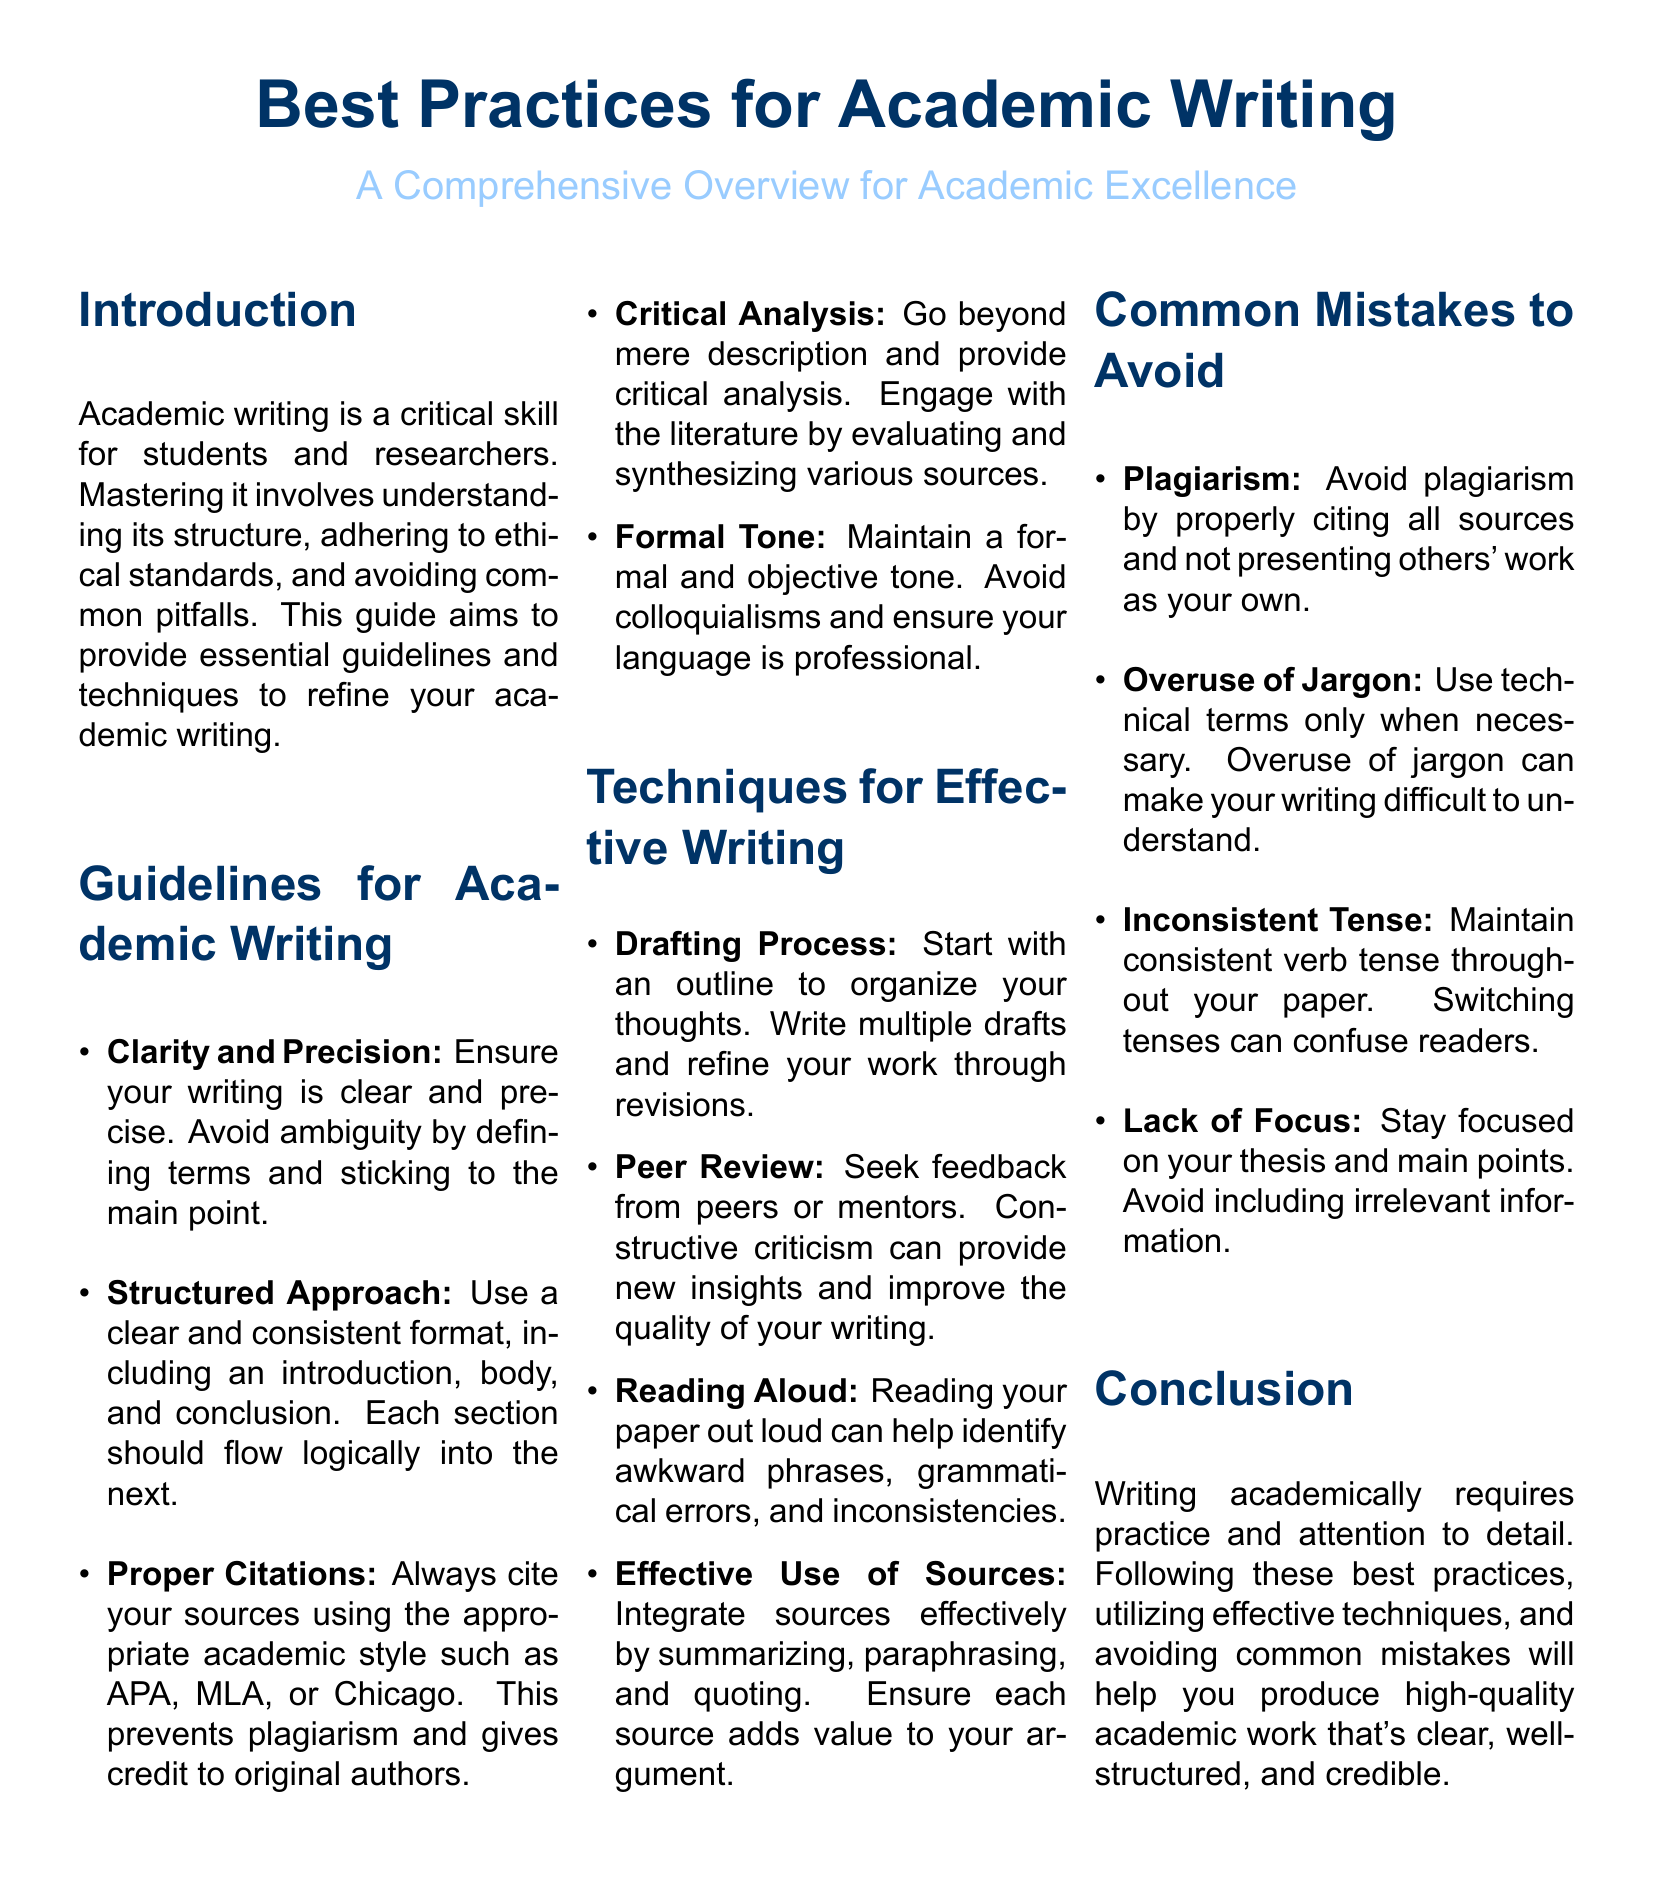What is the document about? The document provides guidelines, techniques, and common mistakes in academic writing aimed at enhancing academic excellence.
Answer: Best Practices for Academic Writing What are the main colors used in the document? The document uses maincolor (RGB: 0,51,102) and secondcolor (RGB: 153,204,255) for its design.
Answer: maincolor and secondcolor How many sections are there in the guidelines for academic writing? The guidelines include five key points related to academic writing, as listed in the document.
Answer: Five What is one common mistake to avoid in academic writing? The document lists plagiarism as one of the common mistakes to avoid in academic writing.
Answer: Plagiarism Which technique involves *organizing your thoughts*? The drafting process is highlighted as a technique for organizing thoughts before writing.
Answer: Drafting Process What tone should be maintained in academic writing? The document advises maintaining a formal and objective tone in writing.
Answer: Formal tone What should be included in a structured approach to writing? A structured approach includes an introduction, body, and conclusion with logical flow.
Answer: Introduction, body, and conclusion How many tips are provided for effective writing? The document outlines four techniques for effective writing specified in the section.
Answer: Four Who can provide constructive criticism to improve writing? Peers or mentors are suggested as sources for constructive criticism in writing.
Answer: Peers or mentors 